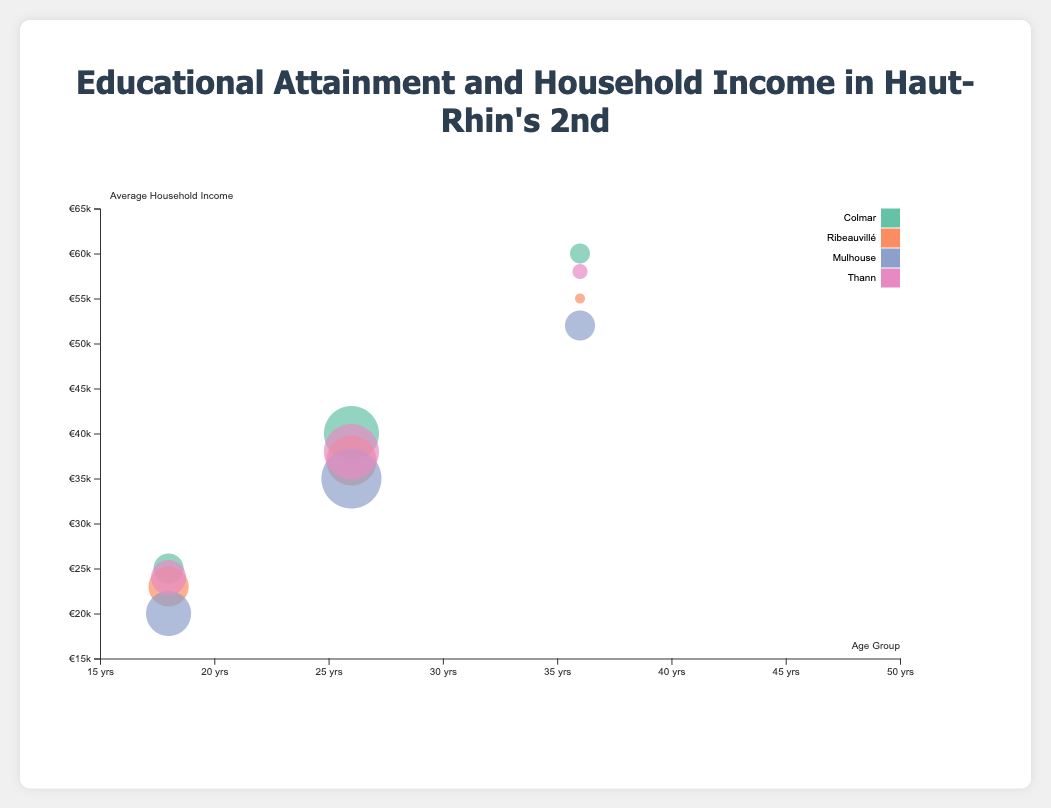What is the average household income for the 26-35 age group in Colmar? By looking at the bubble corresponding to Colmar for the age group 26-35, the tooltip or bubble label shows the average household income.
Answer: 40000 What is the education attainment for the 18-25 age group in Mulhouse? By identifying the bubble pertaining to Mulhouse for the 18-25 age group, the tooltip or bubble label reveals the education attainment level for that group.
Answer: Vocational Training Which district has the highest population percentage for any age group? By comparing the sizes of the bubbles, the largest bubble represents the highest population percentage. Looking at the tooltip or bubble label of the largest bubble for further details provides the answer.
Answer: Mulhouse (26-35 age group) Compare the average household incomes for the 36-45 age group in Colmar and Thann. Which one is higher? By locating the bubbles for the 36-45 age groups in Colmar and Thann, we see their corresponding average household incomes. Colmar’s 36-45 age group average household income is 60000 and Thann’s is 58000.
Answer: Colmar What are the population percentages for the 18-25 age group in Ribeauvillé and Mulhouse combined? Identify the bubbles for the 18-25 age group in Ribeauvillé and Mulhouse, then add their population percentages: Ribeauvillé (22%) and Mulhouse (23%). The combined percentage is 22 + 23 = 45%
Answer: 45% What is the relationship between average household income and education attainment level across all age groups in Colmar? Spotting the bubbles for Colmar across different age groups, we observe: High School (25000), Bachelor's Degree (40000), and Master’s Degree (60000). As the education attainment level increases from High School to Master's Degree, the average household income increases.
Answer: Positive correlation Which age group in Mulhouse has the highest average household income? For Mulhouse, look at the bubble which has the highest vertical position (Y-axis). The tooltip or bubble label reveals that the 36-45 age group has the highest average household income.
Answer: 36-45 age group Is the average household income for the 26-35 age group in Ribeauvillé greater than that in Thann? Compare the corresponding bubbles for the 26-35 age group in both districts. Ribeauvillé’s average household income for this age group is 37000, while Thann’s is 38000, which shows it is not greater.
Answer: No Which district has the lowest average household income for the 18-25 age group? By comparing the vertical position (Y-axis) of the bubbles for the 18-25 age group across all districts, the lowest position represents the lowest average household income. Mulhouse’s bubble for this age group shows an income of 20000.
Answer: Mulhouse What is the arithmetic mean of the average household incomes for the 18-25 age group across all districts? Adding the average household incomes for the 18-25 age group across all districts: 25000 (Colmar), 23000 (Ribeauvillé), 20000 (Mulhouse), and 24000 (Thann), and then dividing by the number of districts (4). (25000 + 23000 + 20000 + 24000) / 4 = 23000
Answer: 23000 